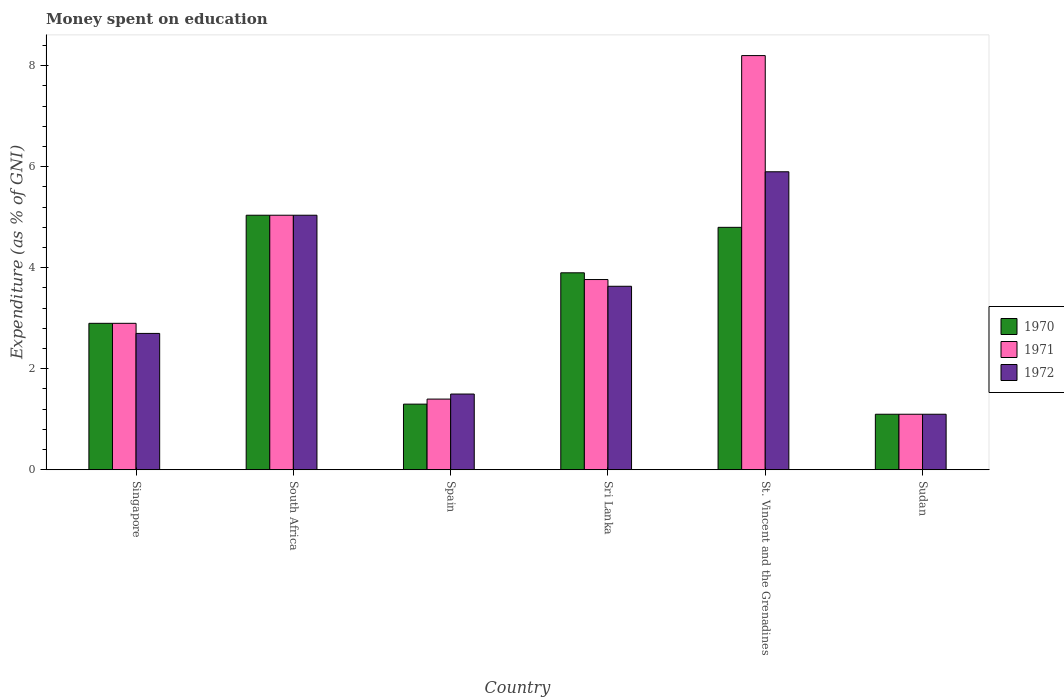Are the number of bars per tick equal to the number of legend labels?
Ensure brevity in your answer.  Yes. Are the number of bars on each tick of the X-axis equal?
Your answer should be very brief. Yes. How many bars are there on the 3rd tick from the right?
Your answer should be very brief. 3. What is the label of the 1st group of bars from the left?
Your answer should be very brief. Singapore. What is the amount of money spent on education in 1971 in Sri Lanka?
Your response must be concise. 3.77. Across all countries, what is the maximum amount of money spent on education in 1970?
Make the answer very short. 5.04. In which country was the amount of money spent on education in 1971 maximum?
Ensure brevity in your answer.  St. Vincent and the Grenadines. In which country was the amount of money spent on education in 1972 minimum?
Your answer should be very brief. Sudan. What is the total amount of money spent on education in 1970 in the graph?
Your response must be concise. 19.04. What is the difference between the amount of money spent on education in 1972 in Singapore and the amount of money spent on education in 1970 in St. Vincent and the Grenadines?
Provide a succinct answer. -2.1. What is the average amount of money spent on education in 1972 per country?
Give a very brief answer. 3.31. What is the difference between the amount of money spent on education of/in 1970 and amount of money spent on education of/in 1972 in Sri Lanka?
Provide a succinct answer. 0.27. What is the ratio of the amount of money spent on education in 1972 in Spain to that in Sri Lanka?
Keep it short and to the point. 0.41. Is the difference between the amount of money spent on education in 1970 in South Africa and Spain greater than the difference between the amount of money spent on education in 1972 in South Africa and Spain?
Give a very brief answer. Yes. What is the difference between the highest and the second highest amount of money spent on education in 1971?
Provide a short and direct response. 4.43. What is the difference between the highest and the lowest amount of money spent on education in 1970?
Make the answer very short. 3.94. In how many countries, is the amount of money spent on education in 1972 greater than the average amount of money spent on education in 1972 taken over all countries?
Your answer should be compact. 3. Is the sum of the amount of money spent on education in 1970 in South Africa and St. Vincent and the Grenadines greater than the maximum amount of money spent on education in 1971 across all countries?
Ensure brevity in your answer.  Yes. How many bars are there?
Give a very brief answer. 18. Are all the bars in the graph horizontal?
Provide a short and direct response. No. Does the graph contain any zero values?
Make the answer very short. No. Does the graph contain grids?
Provide a short and direct response. No. How many legend labels are there?
Provide a short and direct response. 3. How are the legend labels stacked?
Provide a succinct answer. Vertical. What is the title of the graph?
Provide a short and direct response. Money spent on education. Does "2006" appear as one of the legend labels in the graph?
Your answer should be compact. No. What is the label or title of the X-axis?
Ensure brevity in your answer.  Country. What is the label or title of the Y-axis?
Provide a short and direct response. Expenditure (as % of GNI). What is the Expenditure (as % of GNI) of 1971 in Singapore?
Offer a terse response. 2.9. What is the Expenditure (as % of GNI) in 1970 in South Africa?
Offer a very short reply. 5.04. What is the Expenditure (as % of GNI) in 1971 in South Africa?
Provide a short and direct response. 5.04. What is the Expenditure (as % of GNI) of 1972 in South Africa?
Offer a terse response. 5.04. What is the Expenditure (as % of GNI) of 1971 in Spain?
Provide a succinct answer. 1.4. What is the Expenditure (as % of GNI) in 1971 in Sri Lanka?
Keep it short and to the point. 3.77. What is the Expenditure (as % of GNI) of 1972 in Sri Lanka?
Give a very brief answer. 3.63. What is the Expenditure (as % of GNI) in 1971 in St. Vincent and the Grenadines?
Your response must be concise. 8.2. What is the Expenditure (as % of GNI) of 1972 in St. Vincent and the Grenadines?
Offer a terse response. 5.9. What is the Expenditure (as % of GNI) of 1970 in Sudan?
Your answer should be compact. 1.1. What is the Expenditure (as % of GNI) of 1971 in Sudan?
Give a very brief answer. 1.1. Across all countries, what is the maximum Expenditure (as % of GNI) in 1970?
Your answer should be compact. 5.04. Across all countries, what is the maximum Expenditure (as % of GNI) in 1971?
Your answer should be very brief. 8.2. Across all countries, what is the minimum Expenditure (as % of GNI) in 1970?
Offer a very short reply. 1.1. Across all countries, what is the minimum Expenditure (as % of GNI) of 1972?
Offer a very short reply. 1.1. What is the total Expenditure (as % of GNI) in 1970 in the graph?
Your answer should be very brief. 19.04. What is the total Expenditure (as % of GNI) of 1971 in the graph?
Offer a terse response. 22.41. What is the total Expenditure (as % of GNI) in 1972 in the graph?
Your answer should be compact. 19.87. What is the difference between the Expenditure (as % of GNI) in 1970 in Singapore and that in South Africa?
Offer a terse response. -2.14. What is the difference between the Expenditure (as % of GNI) of 1971 in Singapore and that in South Africa?
Offer a very short reply. -2.14. What is the difference between the Expenditure (as % of GNI) of 1972 in Singapore and that in South Africa?
Offer a terse response. -2.34. What is the difference between the Expenditure (as % of GNI) in 1971 in Singapore and that in Spain?
Give a very brief answer. 1.5. What is the difference between the Expenditure (as % of GNI) of 1972 in Singapore and that in Spain?
Offer a terse response. 1.2. What is the difference between the Expenditure (as % of GNI) of 1971 in Singapore and that in Sri Lanka?
Keep it short and to the point. -0.87. What is the difference between the Expenditure (as % of GNI) in 1972 in Singapore and that in Sri Lanka?
Your answer should be compact. -0.93. What is the difference between the Expenditure (as % of GNI) of 1970 in Singapore and that in St. Vincent and the Grenadines?
Your answer should be very brief. -1.9. What is the difference between the Expenditure (as % of GNI) in 1971 in Singapore and that in Sudan?
Provide a short and direct response. 1.8. What is the difference between the Expenditure (as % of GNI) of 1970 in South Africa and that in Spain?
Give a very brief answer. 3.74. What is the difference between the Expenditure (as % of GNI) of 1971 in South Africa and that in Spain?
Offer a very short reply. 3.64. What is the difference between the Expenditure (as % of GNI) in 1972 in South Africa and that in Spain?
Your response must be concise. 3.54. What is the difference between the Expenditure (as % of GNI) in 1970 in South Africa and that in Sri Lanka?
Provide a succinct answer. 1.14. What is the difference between the Expenditure (as % of GNI) in 1971 in South Africa and that in Sri Lanka?
Keep it short and to the point. 1.27. What is the difference between the Expenditure (as % of GNI) of 1972 in South Africa and that in Sri Lanka?
Give a very brief answer. 1.41. What is the difference between the Expenditure (as % of GNI) in 1970 in South Africa and that in St. Vincent and the Grenadines?
Your response must be concise. 0.24. What is the difference between the Expenditure (as % of GNI) in 1971 in South Africa and that in St. Vincent and the Grenadines?
Offer a very short reply. -3.16. What is the difference between the Expenditure (as % of GNI) of 1972 in South Africa and that in St. Vincent and the Grenadines?
Offer a terse response. -0.86. What is the difference between the Expenditure (as % of GNI) in 1970 in South Africa and that in Sudan?
Provide a succinct answer. 3.94. What is the difference between the Expenditure (as % of GNI) in 1971 in South Africa and that in Sudan?
Ensure brevity in your answer.  3.94. What is the difference between the Expenditure (as % of GNI) in 1972 in South Africa and that in Sudan?
Offer a very short reply. 3.94. What is the difference between the Expenditure (as % of GNI) in 1971 in Spain and that in Sri Lanka?
Ensure brevity in your answer.  -2.37. What is the difference between the Expenditure (as % of GNI) in 1972 in Spain and that in Sri Lanka?
Provide a succinct answer. -2.13. What is the difference between the Expenditure (as % of GNI) of 1970 in Spain and that in St. Vincent and the Grenadines?
Your answer should be very brief. -3.5. What is the difference between the Expenditure (as % of GNI) of 1971 in Spain and that in St. Vincent and the Grenadines?
Keep it short and to the point. -6.8. What is the difference between the Expenditure (as % of GNI) in 1972 in Spain and that in St. Vincent and the Grenadines?
Your answer should be very brief. -4.4. What is the difference between the Expenditure (as % of GNI) of 1970 in Spain and that in Sudan?
Provide a succinct answer. 0.2. What is the difference between the Expenditure (as % of GNI) of 1971 in Spain and that in Sudan?
Ensure brevity in your answer.  0.3. What is the difference between the Expenditure (as % of GNI) in 1971 in Sri Lanka and that in St. Vincent and the Grenadines?
Offer a terse response. -4.43. What is the difference between the Expenditure (as % of GNI) in 1972 in Sri Lanka and that in St. Vincent and the Grenadines?
Your response must be concise. -2.27. What is the difference between the Expenditure (as % of GNI) in 1970 in Sri Lanka and that in Sudan?
Your response must be concise. 2.8. What is the difference between the Expenditure (as % of GNI) in 1971 in Sri Lanka and that in Sudan?
Provide a short and direct response. 2.67. What is the difference between the Expenditure (as % of GNI) of 1972 in Sri Lanka and that in Sudan?
Make the answer very short. 2.53. What is the difference between the Expenditure (as % of GNI) in 1971 in St. Vincent and the Grenadines and that in Sudan?
Provide a short and direct response. 7.1. What is the difference between the Expenditure (as % of GNI) of 1970 in Singapore and the Expenditure (as % of GNI) of 1971 in South Africa?
Your answer should be compact. -2.14. What is the difference between the Expenditure (as % of GNI) of 1970 in Singapore and the Expenditure (as % of GNI) of 1972 in South Africa?
Give a very brief answer. -2.14. What is the difference between the Expenditure (as % of GNI) in 1971 in Singapore and the Expenditure (as % of GNI) in 1972 in South Africa?
Make the answer very short. -2.14. What is the difference between the Expenditure (as % of GNI) of 1971 in Singapore and the Expenditure (as % of GNI) of 1972 in Spain?
Make the answer very short. 1.4. What is the difference between the Expenditure (as % of GNI) of 1970 in Singapore and the Expenditure (as % of GNI) of 1971 in Sri Lanka?
Your answer should be compact. -0.87. What is the difference between the Expenditure (as % of GNI) in 1970 in Singapore and the Expenditure (as % of GNI) in 1972 in Sri Lanka?
Provide a succinct answer. -0.73. What is the difference between the Expenditure (as % of GNI) of 1971 in Singapore and the Expenditure (as % of GNI) of 1972 in Sri Lanka?
Give a very brief answer. -0.73. What is the difference between the Expenditure (as % of GNI) in 1970 in Singapore and the Expenditure (as % of GNI) in 1971 in St. Vincent and the Grenadines?
Ensure brevity in your answer.  -5.3. What is the difference between the Expenditure (as % of GNI) of 1971 in Singapore and the Expenditure (as % of GNI) of 1972 in St. Vincent and the Grenadines?
Provide a short and direct response. -3. What is the difference between the Expenditure (as % of GNI) of 1970 in South Africa and the Expenditure (as % of GNI) of 1971 in Spain?
Your response must be concise. 3.64. What is the difference between the Expenditure (as % of GNI) in 1970 in South Africa and the Expenditure (as % of GNI) in 1972 in Spain?
Give a very brief answer. 3.54. What is the difference between the Expenditure (as % of GNI) of 1971 in South Africa and the Expenditure (as % of GNI) of 1972 in Spain?
Your response must be concise. 3.54. What is the difference between the Expenditure (as % of GNI) of 1970 in South Africa and the Expenditure (as % of GNI) of 1971 in Sri Lanka?
Your answer should be very brief. 1.27. What is the difference between the Expenditure (as % of GNI) in 1970 in South Africa and the Expenditure (as % of GNI) in 1972 in Sri Lanka?
Provide a short and direct response. 1.41. What is the difference between the Expenditure (as % of GNI) of 1971 in South Africa and the Expenditure (as % of GNI) of 1972 in Sri Lanka?
Give a very brief answer. 1.41. What is the difference between the Expenditure (as % of GNI) of 1970 in South Africa and the Expenditure (as % of GNI) of 1971 in St. Vincent and the Grenadines?
Give a very brief answer. -3.16. What is the difference between the Expenditure (as % of GNI) in 1970 in South Africa and the Expenditure (as % of GNI) in 1972 in St. Vincent and the Grenadines?
Ensure brevity in your answer.  -0.86. What is the difference between the Expenditure (as % of GNI) of 1971 in South Africa and the Expenditure (as % of GNI) of 1972 in St. Vincent and the Grenadines?
Keep it short and to the point. -0.86. What is the difference between the Expenditure (as % of GNI) of 1970 in South Africa and the Expenditure (as % of GNI) of 1971 in Sudan?
Provide a succinct answer. 3.94. What is the difference between the Expenditure (as % of GNI) of 1970 in South Africa and the Expenditure (as % of GNI) of 1972 in Sudan?
Make the answer very short. 3.94. What is the difference between the Expenditure (as % of GNI) in 1971 in South Africa and the Expenditure (as % of GNI) in 1972 in Sudan?
Your answer should be compact. 3.94. What is the difference between the Expenditure (as % of GNI) of 1970 in Spain and the Expenditure (as % of GNI) of 1971 in Sri Lanka?
Make the answer very short. -2.47. What is the difference between the Expenditure (as % of GNI) of 1970 in Spain and the Expenditure (as % of GNI) of 1972 in Sri Lanka?
Offer a very short reply. -2.33. What is the difference between the Expenditure (as % of GNI) in 1971 in Spain and the Expenditure (as % of GNI) in 1972 in Sri Lanka?
Your response must be concise. -2.23. What is the difference between the Expenditure (as % of GNI) in 1970 in Spain and the Expenditure (as % of GNI) in 1971 in St. Vincent and the Grenadines?
Your answer should be compact. -6.9. What is the difference between the Expenditure (as % of GNI) in 1971 in Spain and the Expenditure (as % of GNI) in 1972 in St. Vincent and the Grenadines?
Your answer should be very brief. -4.5. What is the difference between the Expenditure (as % of GNI) of 1970 in Spain and the Expenditure (as % of GNI) of 1971 in Sudan?
Your answer should be compact. 0.2. What is the difference between the Expenditure (as % of GNI) in 1970 in Sri Lanka and the Expenditure (as % of GNI) in 1971 in St. Vincent and the Grenadines?
Your answer should be compact. -4.3. What is the difference between the Expenditure (as % of GNI) of 1971 in Sri Lanka and the Expenditure (as % of GNI) of 1972 in St. Vincent and the Grenadines?
Provide a short and direct response. -2.13. What is the difference between the Expenditure (as % of GNI) in 1970 in Sri Lanka and the Expenditure (as % of GNI) in 1972 in Sudan?
Your answer should be compact. 2.8. What is the difference between the Expenditure (as % of GNI) in 1971 in Sri Lanka and the Expenditure (as % of GNI) in 1972 in Sudan?
Your answer should be compact. 2.67. What is the difference between the Expenditure (as % of GNI) of 1970 in St. Vincent and the Grenadines and the Expenditure (as % of GNI) of 1971 in Sudan?
Your answer should be very brief. 3.7. What is the difference between the Expenditure (as % of GNI) of 1971 in St. Vincent and the Grenadines and the Expenditure (as % of GNI) of 1972 in Sudan?
Offer a terse response. 7.1. What is the average Expenditure (as % of GNI) in 1970 per country?
Provide a short and direct response. 3.17. What is the average Expenditure (as % of GNI) in 1971 per country?
Your answer should be very brief. 3.73. What is the average Expenditure (as % of GNI) in 1972 per country?
Provide a succinct answer. 3.31. What is the difference between the Expenditure (as % of GNI) of 1970 and Expenditure (as % of GNI) of 1971 in Singapore?
Ensure brevity in your answer.  0. What is the difference between the Expenditure (as % of GNI) of 1970 and Expenditure (as % of GNI) of 1972 in Singapore?
Provide a succinct answer. 0.2. What is the difference between the Expenditure (as % of GNI) in 1971 and Expenditure (as % of GNI) in 1972 in Singapore?
Your answer should be compact. 0.2. What is the difference between the Expenditure (as % of GNI) in 1970 and Expenditure (as % of GNI) in 1971 in South Africa?
Your answer should be compact. 0. What is the difference between the Expenditure (as % of GNI) in 1970 and Expenditure (as % of GNI) in 1972 in South Africa?
Your answer should be compact. 0. What is the difference between the Expenditure (as % of GNI) in 1970 and Expenditure (as % of GNI) in 1971 in Spain?
Offer a very short reply. -0.1. What is the difference between the Expenditure (as % of GNI) of 1970 and Expenditure (as % of GNI) of 1972 in Spain?
Offer a very short reply. -0.2. What is the difference between the Expenditure (as % of GNI) of 1970 and Expenditure (as % of GNI) of 1971 in Sri Lanka?
Keep it short and to the point. 0.13. What is the difference between the Expenditure (as % of GNI) of 1970 and Expenditure (as % of GNI) of 1972 in Sri Lanka?
Ensure brevity in your answer.  0.27. What is the difference between the Expenditure (as % of GNI) of 1971 and Expenditure (as % of GNI) of 1972 in Sri Lanka?
Your answer should be compact. 0.13. What is the difference between the Expenditure (as % of GNI) in 1970 and Expenditure (as % of GNI) in 1972 in St. Vincent and the Grenadines?
Give a very brief answer. -1.1. What is the difference between the Expenditure (as % of GNI) of 1970 and Expenditure (as % of GNI) of 1971 in Sudan?
Offer a terse response. 0. What is the difference between the Expenditure (as % of GNI) of 1971 and Expenditure (as % of GNI) of 1972 in Sudan?
Your answer should be compact. 0. What is the ratio of the Expenditure (as % of GNI) of 1970 in Singapore to that in South Africa?
Ensure brevity in your answer.  0.58. What is the ratio of the Expenditure (as % of GNI) in 1971 in Singapore to that in South Africa?
Provide a succinct answer. 0.58. What is the ratio of the Expenditure (as % of GNI) of 1972 in Singapore to that in South Africa?
Provide a succinct answer. 0.54. What is the ratio of the Expenditure (as % of GNI) in 1970 in Singapore to that in Spain?
Provide a short and direct response. 2.23. What is the ratio of the Expenditure (as % of GNI) of 1971 in Singapore to that in Spain?
Give a very brief answer. 2.07. What is the ratio of the Expenditure (as % of GNI) of 1970 in Singapore to that in Sri Lanka?
Offer a very short reply. 0.74. What is the ratio of the Expenditure (as % of GNI) of 1971 in Singapore to that in Sri Lanka?
Your answer should be compact. 0.77. What is the ratio of the Expenditure (as % of GNI) of 1972 in Singapore to that in Sri Lanka?
Offer a very short reply. 0.74. What is the ratio of the Expenditure (as % of GNI) of 1970 in Singapore to that in St. Vincent and the Grenadines?
Provide a succinct answer. 0.6. What is the ratio of the Expenditure (as % of GNI) in 1971 in Singapore to that in St. Vincent and the Grenadines?
Your answer should be very brief. 0.35. What is the ratio of the Expenditure (as % of GNI) in 1972 in Singapore to that in St. Vincent and the Grenadines?
Ensure brevity in your answer.  0.46. What is the ratio of the Expenditure (as % of GNI) in 1970 in Singapore to that in Sudan?
Your response must be concise. 2.64. What is the ratio of the Expenditure (as % of GNI) in 1971 in Singapore to that in Sudan?
Keep it short and to the point. 2.64. What is the ratio of the Expenditure (as % of GNI) of 1972 in Singapore to that in Sudan?
Provide a succinct answer. 2.45. What is the ratio of the Expenditure (as % of GNI) of 1970 in South Africa to that in Spain?
Your answer should be compact. 3.88. What is the ratio of the Expenditure (as % of GNI) of 1971 in South Africa to that in Spain?
Provide a short and direct response. 3.6. What is the ratio of the Expenditure (as % of GNI) of 1972 in South Africa to that in Spain?
Keep it short and to the point. 3.36. What is the ratio of the Expenditure (as % of GNI) in 1970 in South Africa to that in Sri Lanka?
Provide a short and direct response. 1.29. What is the ratio of the Expenditure (as % of GNI) in 1971 in South Africa to that in Sri Lanka?
Provide a succinct answer. 1.34. What is the ratio of the Expenditure (as % of GNI) of 1972 in South Africa to that in Sri Lanka?
Provide a succinct answer. 1.39. What is the ratio of the Expenditure (as % of GNI) of 1970 in South Africa to that in St. Vincent and the Grenadines?
Give a very brief answer. 1.05. What is the ratio of the Expenditure (as % of GNI) in 1971 in South Africa to that in St. Vincent and the Grenadines?
Provide a short and direct response. 0.61. What is the ratio of the Expenditure (as % of GNI) in 1972 in South Africa to that in St. Vincent and the Grenadines?
Offer a very short reply. 0.85. What is the ratio of the Expenditure (as % of GNI) of 1970 in South Africa to that in Sudan?
Provide a succinct answer. 4.58. What is the ratio of the Expenditure (as % of GNI) of 1971 in South Africa to that in Sudan?
Give a very brief answer. 4.58. What is the ratio of the Expenditure (as % of GNI) of 1972 in South Africa to that in Sudan?
Your answer should be compact. 4.58. What is the ratio of the Expenditure (as % of GNI) of 1971 in Spain to that in Sri Lanka?
Your answer should be compact. 0.37. What is the ratio of the Expenditure (as % of GNI) of 1972 in Spain to that in Sri Lanka?
Offer a very short reply. 0.41. What is the ratio of the Expenditure (as % of GNI) in 1970 in Spain to that in St. Vincent and the Grenadines?
Offer a very short reply. 0.27. What is the ratio of the Expenditure (as % of GNI) of 1971 in Spain to that in St. Vincent and the Grenadines?
Keep it short and to the point. 0.17. What is the ratio of the Expenditure (as % of GNI) of 1972 in Spain to that in St. Vincent and the Grenadines?
Make the answer very short. 0.25. What is the ratio of the Expenditure (as % of GNI) in 1970 in Spain to that in Sudan?
Make the answer very short. 1.18. What is the ratio of the Expenditure (as % of GNI) in 1971 in Spain to that in Sudan?
Give a very brief answer. 1.27. What is the ratio of the Expenditure (as % of GNI) of 1972 in Spain to that in Sudan?
Offer a very short reply. 1.36. What is the ratio of the Expenditure (as % of GNI) of 1970 in Sri Lanka to that in St. Vincent and the Grenadines?
Offer a very short reply. 0.81. What is the ratio of the Expenditure (as % of GNI) of 1971 in Sri Lanka to that in St. Vincent and the Grenadines?
Make the answer very short. 0.46. What is the ratio of the Expenditure (as % of GNI) of 1972 in Sri Lanka to that in St. Vincent and the Grenadines?
Keep it short and to the point. 0.62. What is the ratio of the Expenditure (as % of GNI) of 1970 in Sri Lanka to that in Sudan?
Your answer should be compact. 3.55. What is the ratio of the Expenditure (as % of GNI) in 1971 in Sri Lanka to that in Sudan?
Provide a short and direct response. 3.42. What is the ratio of the Expenditure (as % of GNI) in 1972 in Sri Lanka to that in Sudan?
Your answer should be compact. 3.3. What is the ratio of the Expenditure (as % of GNI) of 1970 in St. Vincent and the Grenadines to that in Sudan?
Keep it short and to the point. 4.36. What is the ratio of the Expenditure (as % of GNI) in 1971 in St. Vincent and the Grenadines to that in Sudan?
Provide a short and direct response. 7.45. What is the ratio of the Expenditure (as % of GNI) of 1972 in St. Vincent and the Grenadines to that in Sudan?
Your answer should be compact. 5.36. What is the difference between the highest and the second highest Expenditure (as % of GNI) of 1970?
Your answer should be very brief. 0.24. What is the difference between the highest and the second highest Expenditure (as % of GNI) in 1971?
Your response must be concise. 3.16. What is the difference between the highest and the second highest Expenditure (as % of GNI) in 1972?
Make the answer very short. 0.86. What is the difference between the highest and the lowest Expenditure (as % of GNI) of 1970?
Offer a very short reply. 3.94. What is the difference between the highest and the lowest Expenditure (as % of GNI) in 1971?
Offer a terse response. 7.1. What is the difference between the highest and the lowest Expenditure (as % of GNI) in 1972?
Your answer should be very brief. 4.8. 